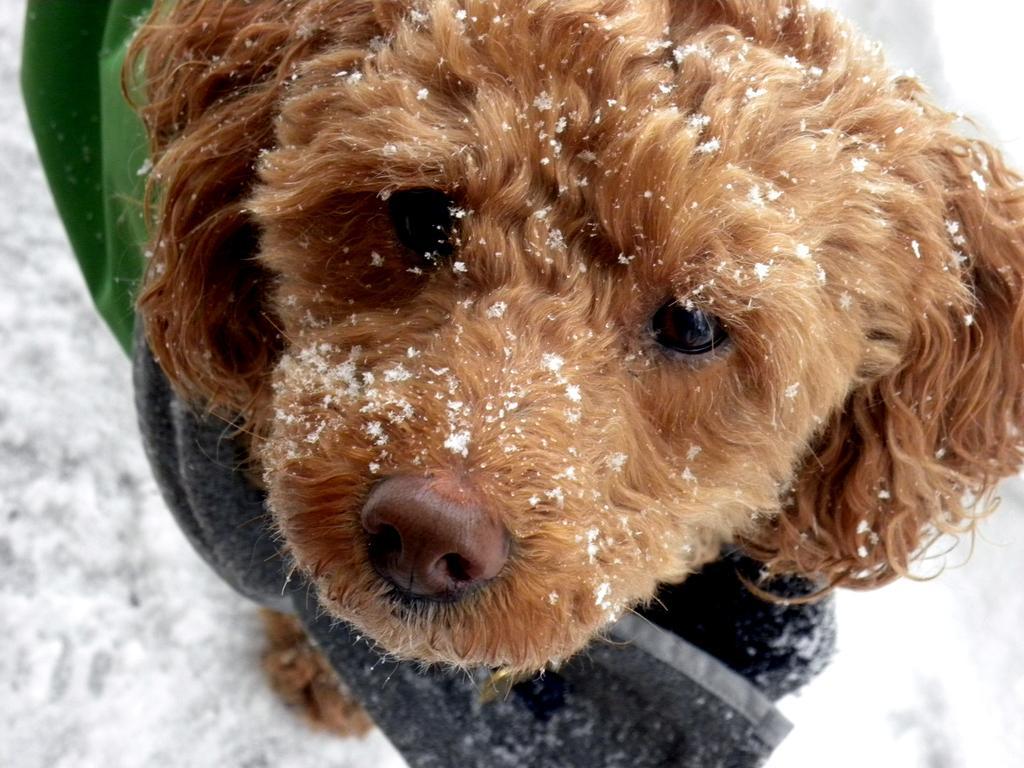Can you describe this image briefly? In this image I can see a dog which is in brown color. I can see a green and black color cloth and a snow. 